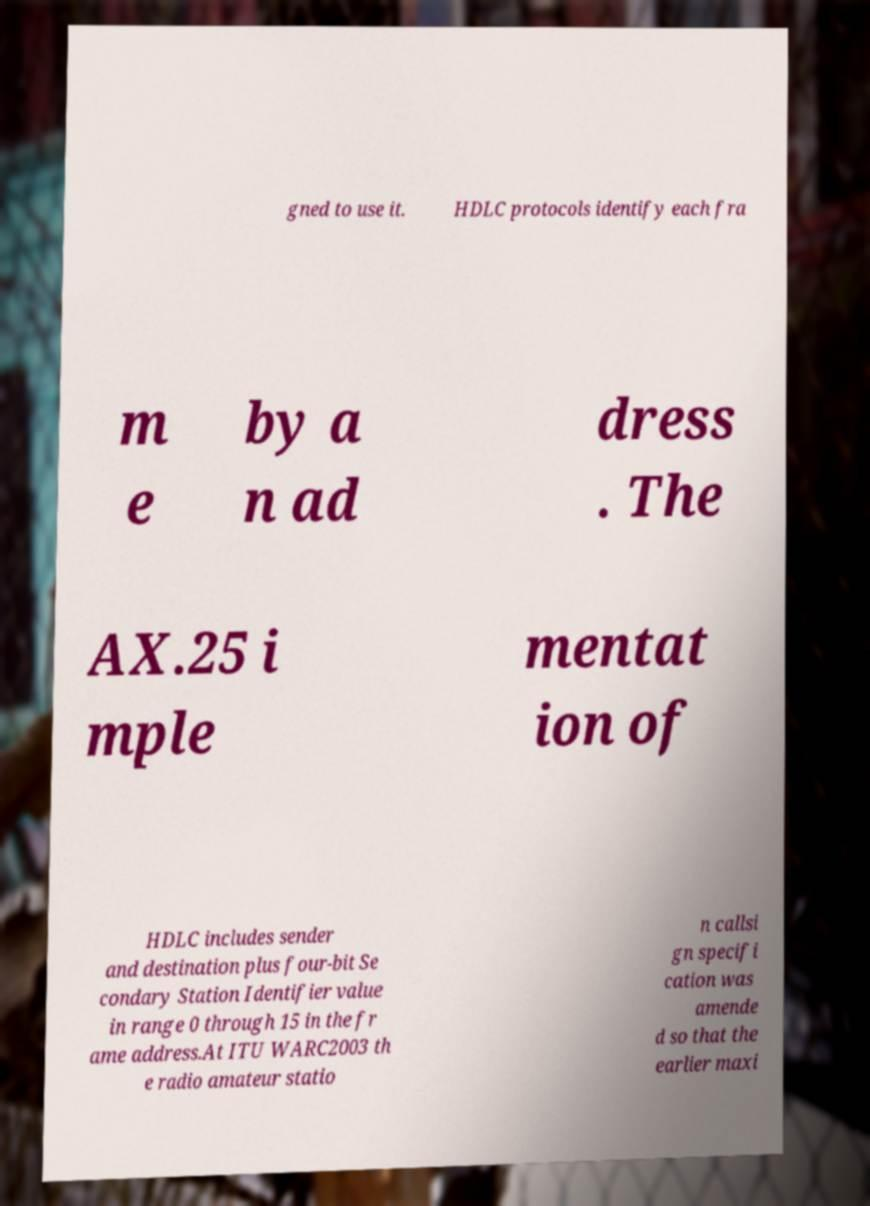I need the written content from this picture converted into text. Can you do that? gned to use it. HDLC protocols identify each fra m e by a n ad dress . The AX.25 i mple mentat ion of HDLC includes sender and destination plus four-bit Se condary Station Identifier value in range 0 through 15 in the fr ame address.At ITU WARC2003 th e radio amateur statio n callsi gn specifi cation was amende d so that the earlier maxi 